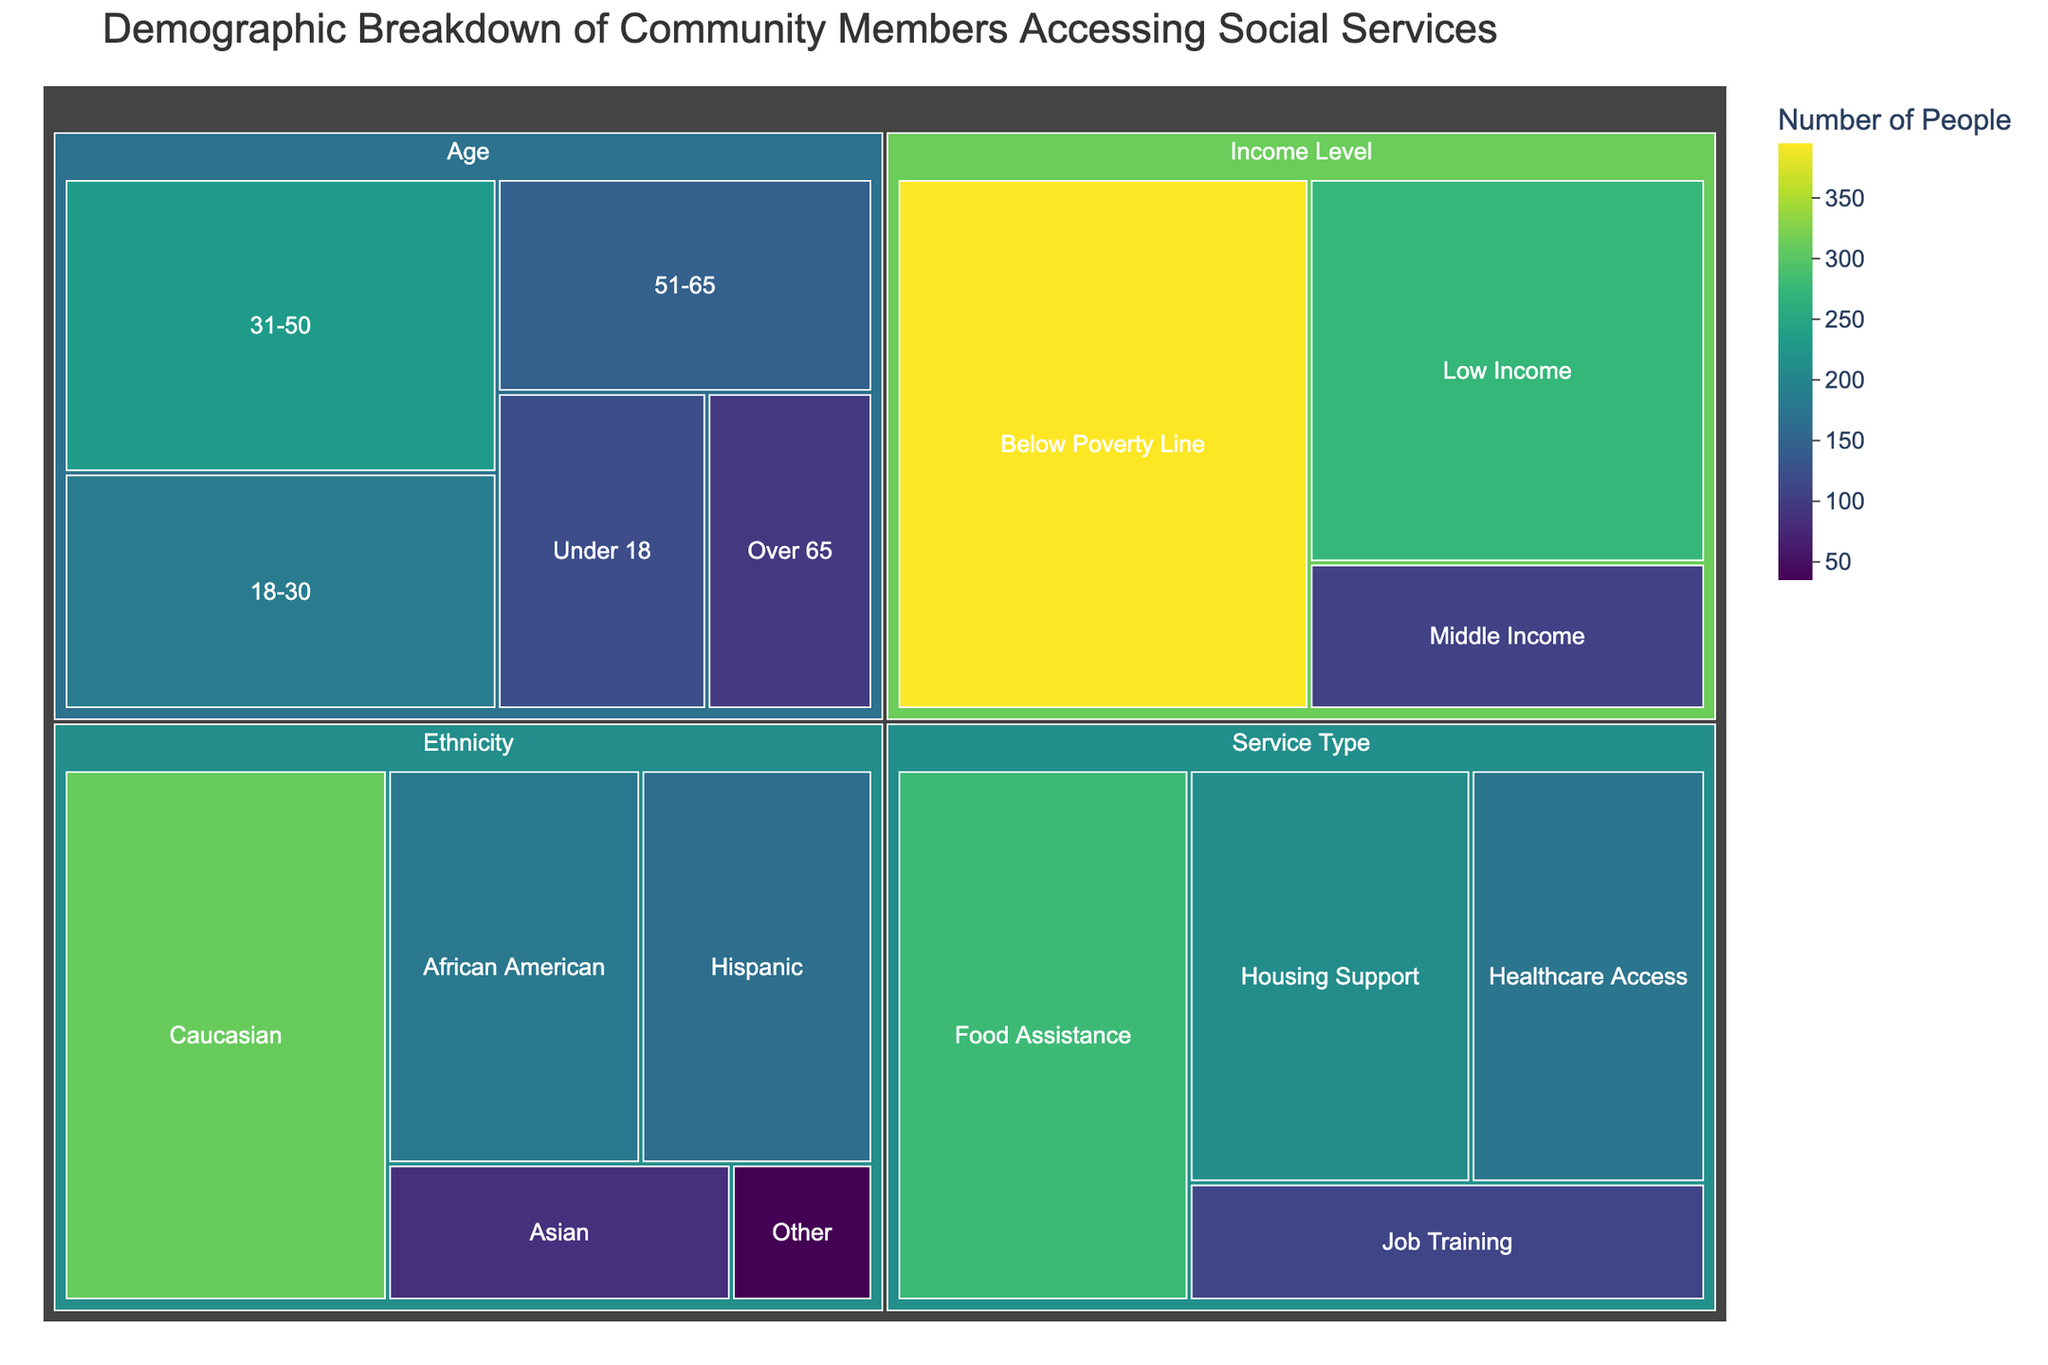What is the highest value in the Age category? Look at the Age category's subcategories. The highest value among "Under 18," "18-30," "31-50," "51-65," and "Over 65" is 230 for the "31-50" group.
Answer: 230 What is the total number of community members accessing services? Sum all the values from the data: 120 + 185 + 230 + 145 + 95 + 310 + 180 + 165 + 85 + 35 + 395 + 275 + 105 + 280 + 210 + 175 + 110 = 2705.
Answer: 2705 Which Ethnicity has the smallest representation in the dataset? Compare the values of the Ethnicity subcategories: "Caucasian," "African American," "Hispanic," "Asian," and "Other." The smallest value is 35 for "Other."
Answer: Other How does the number of people accessing Food Assistance compare to those accessing Housing Support? Look at the values for "Food Assistance" (280) and "Housing Support" (210). The number for "Food Assistance" is greater.
Answer: Food Assistance is greater Are there more people in the Below Poverty Line income level or the combined total of Middle Income and Low Income? Sum the values of "Middle Income" (105) and "Low Income" (275) which equals 380. There are 395 people in the "Below Poverty Line" category, so there are more people in the "Below Poverty Line" category.
Answer: Below Poverty Line is greater Which demographic has the largest single group of people accessing social services? Look at all values across Age, Ethnicity, Income Level, and Service Type categories. The largest value is 395 for "Below Poverty Line" under Income Level.
Answer: Below Poverty Line What is the average number of community members across all Service Types? Sum the values for Service Types (280 + 210 + 175 + 110) = 775. There are 4 service types, so the average is 775/4 = 193.75.
Answer: 193.75 Which age group has fewer members than the "18-30" group? The "18-30" group has 185 members. The groups with fewer members are "Under 18" (120), "51-65" (145), and "Over 65" (95).
Answer: Under 18, 51-65, Over 65 How many more people are there in the "Low Income" category than in the "Middle Income" category? Subtract the value of "Middle Income" (105) from "Low Income" (275). The difference is 275 - 105 = 170.
Answer: 170 Which category has the most subcategories, and how many does it have? Look at each category: Age (5 subcategories), Ethnicity (5 subcategories), Income Level (3 subcategories), Service Type (4 subcategories). The categories with the most subcategories are Age and Ethnicity, each having 5 subcategories.
Answer: Age and Ethnicity, 5 each 